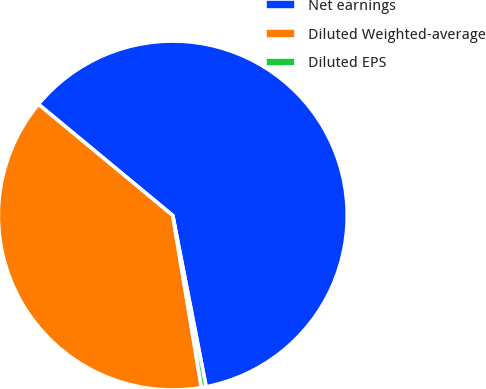Convert chart to OTSL. <chart><loc_0><loc_0><loc_500><loc_500><pie_chart><fcel>Net earnings<fcel>Diluted Weighted-average<fcel>Diluted EPS<nl><fcel>60.93%<fcel>38.64%<fcel>0.43%<nl></chart> 